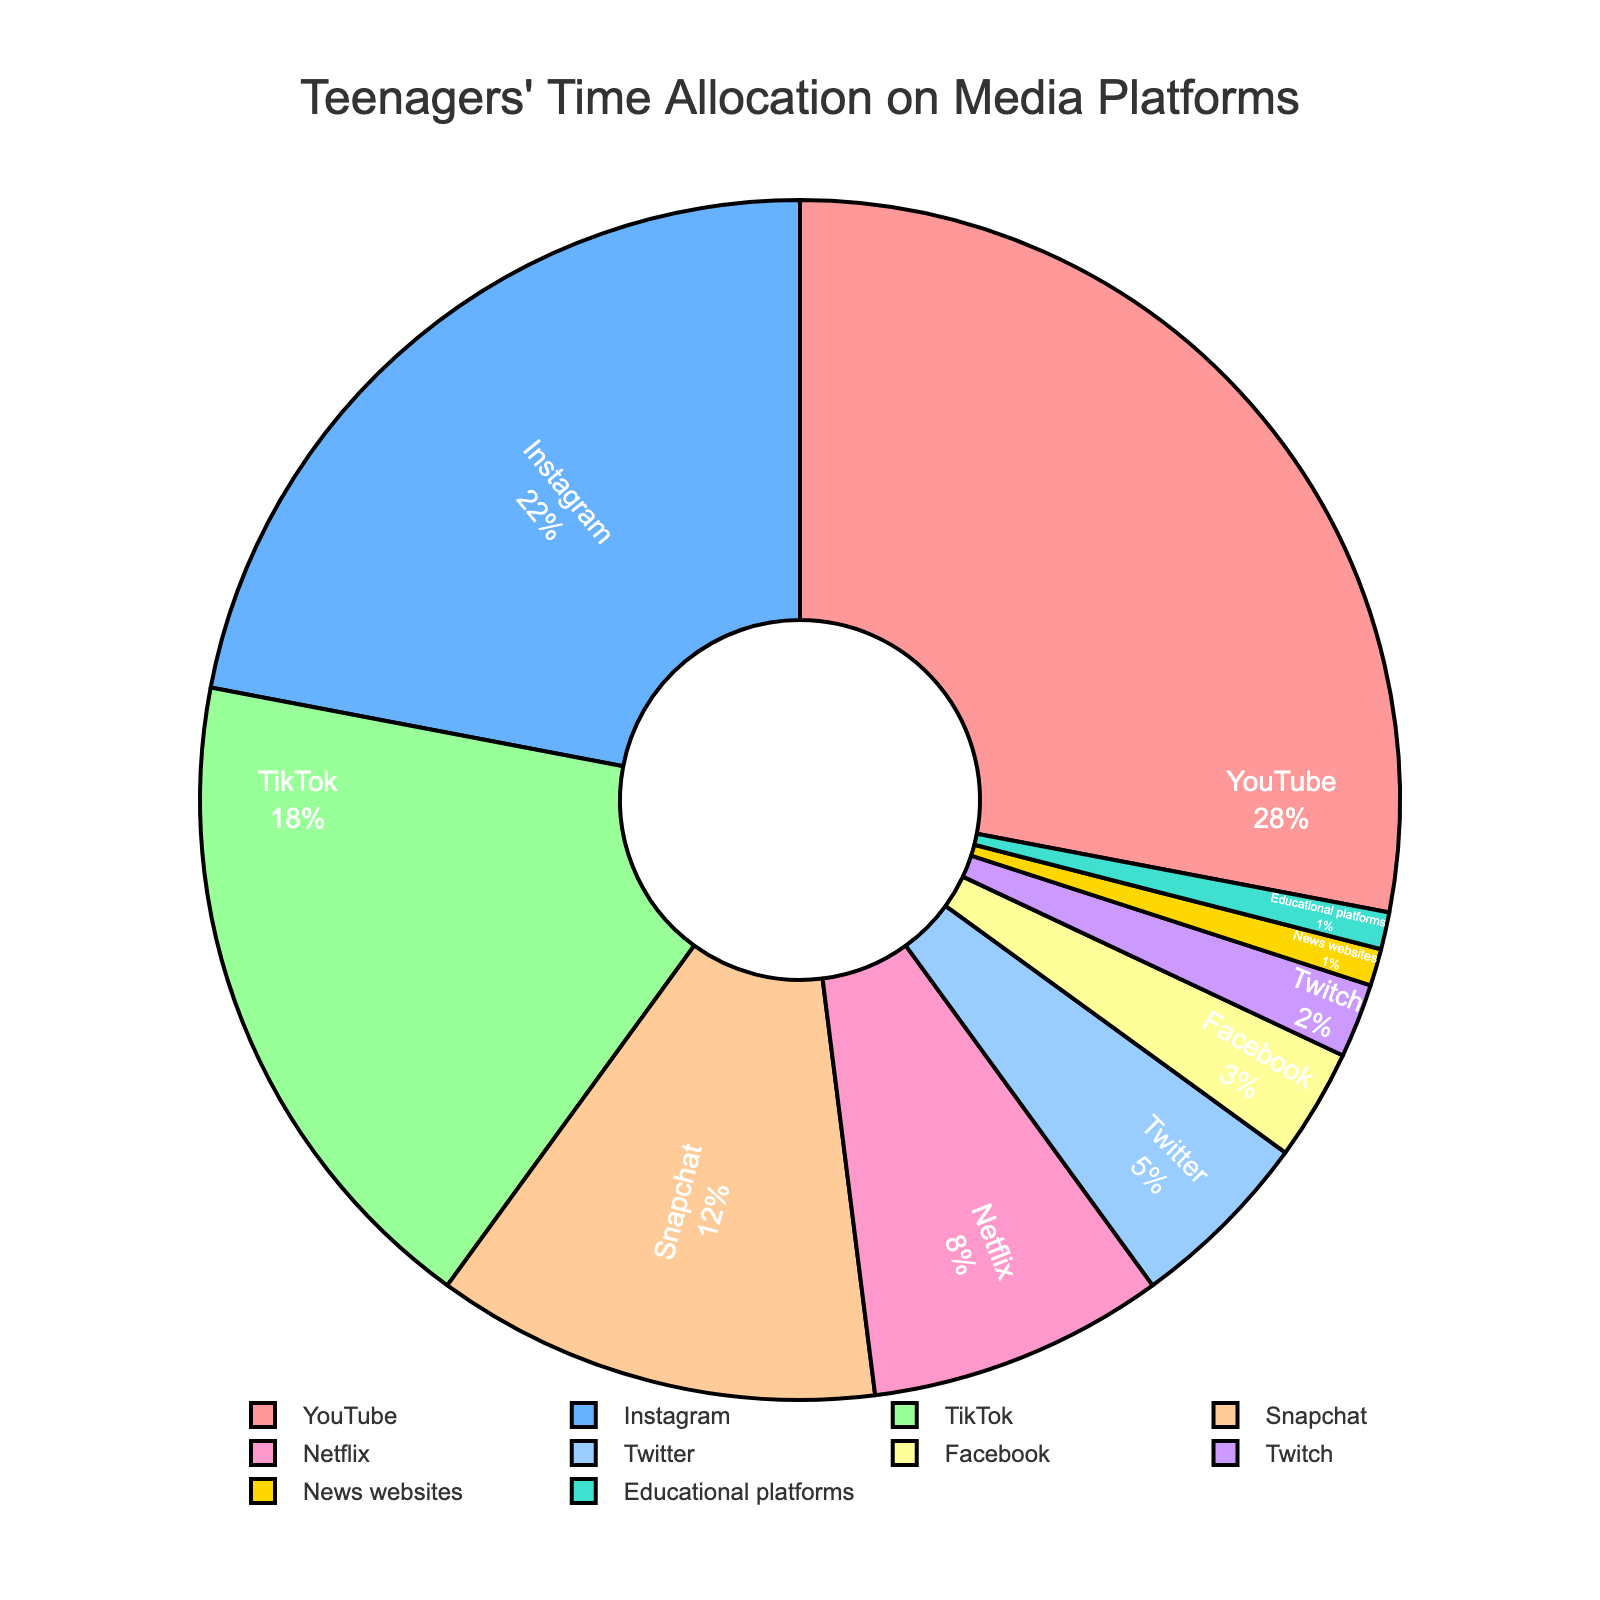What percentage of time do teenagers spend on YouTube and Instagram combined? YouTube and Instagram are the top two platforms. Adding their percentages: 28% (YouTube) + 22% (Instagram) = 50%.
Answer: 50% Which platform do teenagers spend more time on, TikTok or Snapchat? Comparing the percentages, TikTok is 18% and Snapchat is 12%. TikTok has a higher percentage.
Answer: TikTok How much more time do teenagers spend on Netflix than on Facebook? Subtracting Facebook's percentage from Netflix's: 8% (Netflix) - 3% (Facebook) = 5%.
Answer: 5% What is the total percentage of time spent on platforms other than YouTube, Instagram, and TikTok? Adding the percentages of Snapchat, Netflix, Twitter, Facebook, Twitch, News websites, and Educational platforms: 12% + 8% + 5% + 3% + 2% + 1% + 1% = 32%.
Answer: 32% Which platform do teenagers spend the least amount of time on? The platform with the lowest percentage is 1%, and it applies to both News websites and Educational platforms.
Answer: News websites, Educational platforms What is the combined percentage of time spent on Twitter, Facebook, and Twitch? Adding the percentages of Twitter, Facebook, and Twitch: 5% + 3% + 2% = 10%.
Answer: 10% By how much does the time spent on Instagram exceed the time spent on Snapchat? Subtracting Snapchat's percentage from Instagram's: 22% (Instagram) - 12% (Snapchat) = 10%.
Answer: 10% What percentage of time is spent on YouTube compared to other platforms combined? Subtracting YouTube's percentage from 100%: 100% - 28% = 72%.
Answer: 72% Which color represents the platform on which teenagers spend the most time? The color representing YouTube on the chart is red.
Answer: Red 